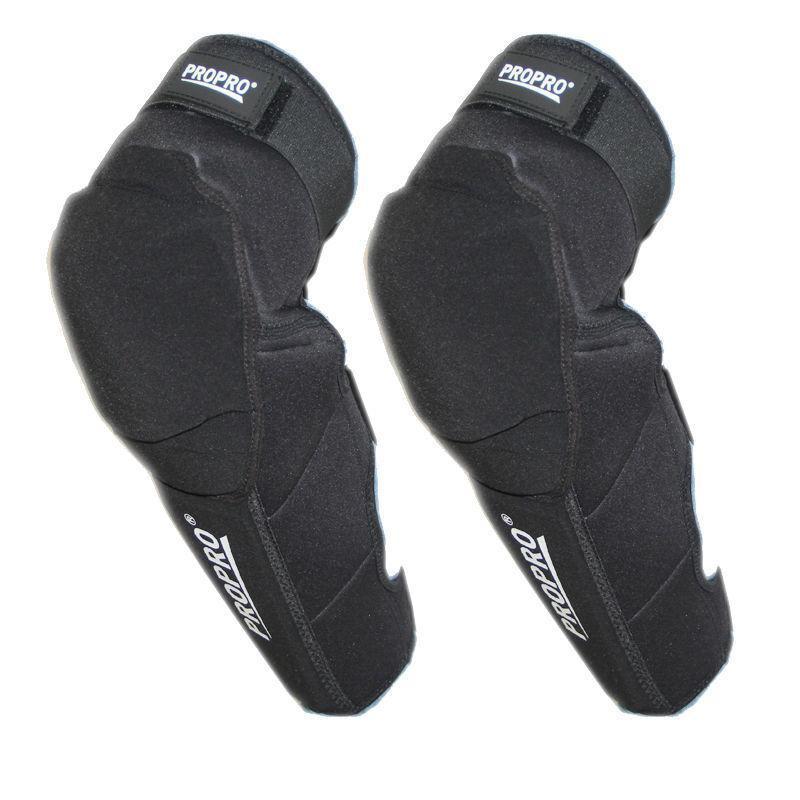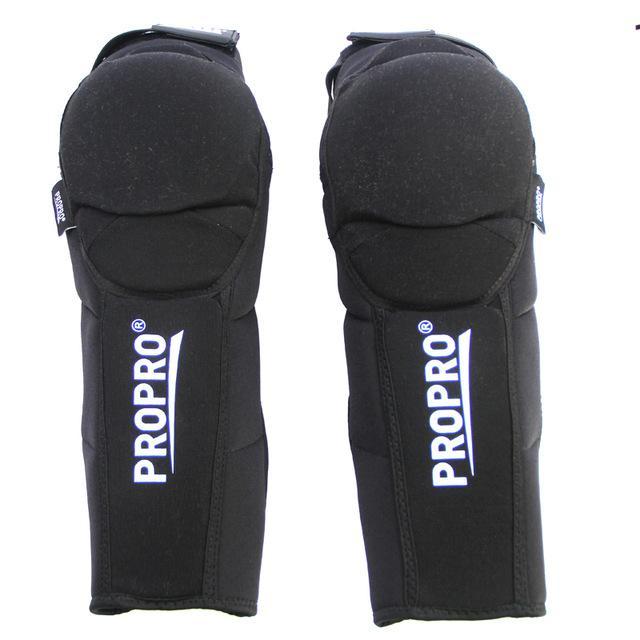The first image is the image on the left, the second image is the image on the right. Examine the images to the left and right. Is the description "The pads are demonstrated on at least one leg." accurate? Answer yes or no. No. 